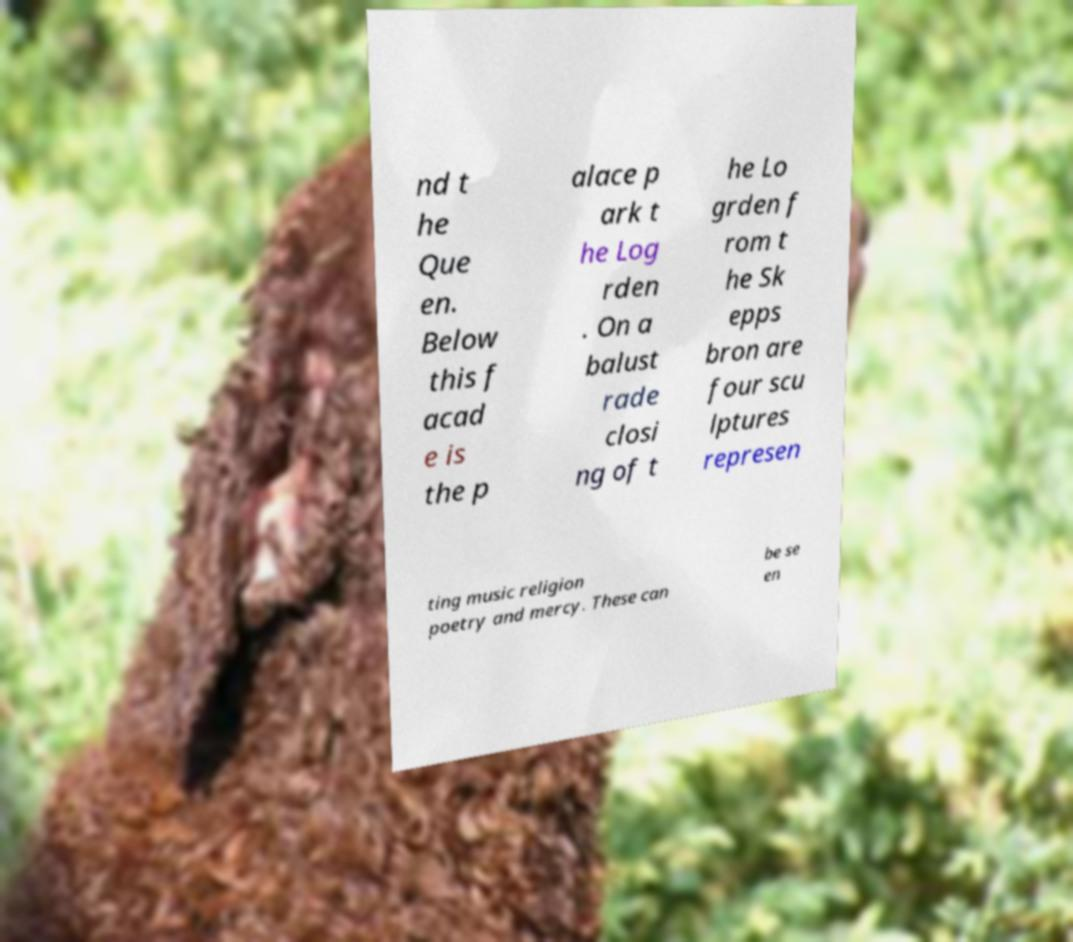Please read and relay the text visible in this image. What does it say? nd t he Que en. Below this f acad e is the p alace p ark t he Log rden . On a balust rade closi ng of t he Lo grden f rom t he Sk epps bron are four scu lptures represen ting music religion poetry and mercy. These can be se en 